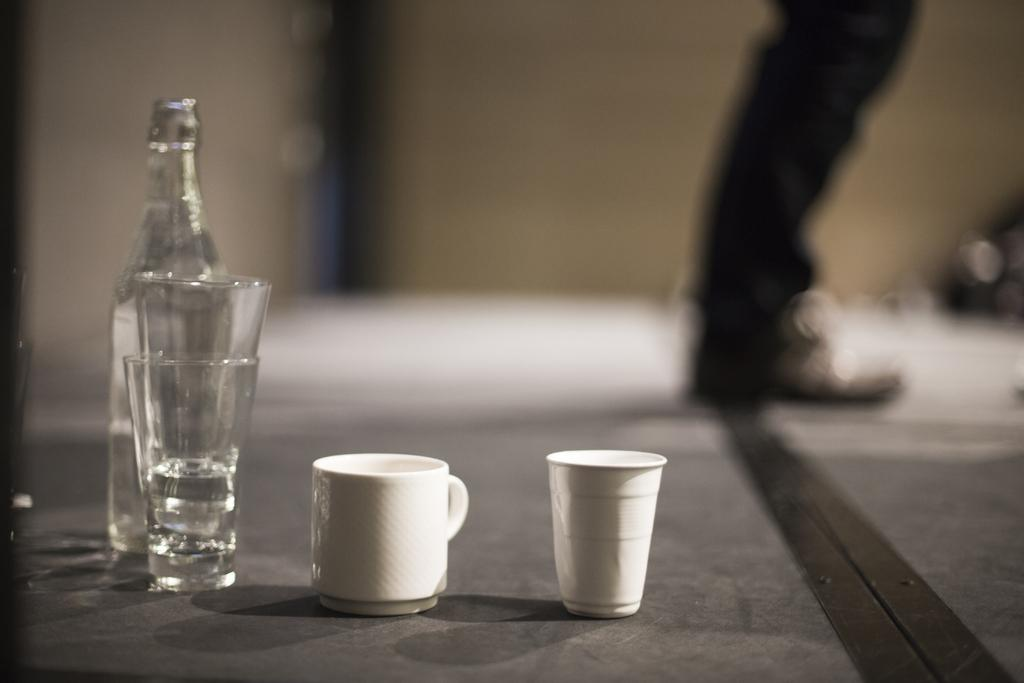What type of container is present in the image? There is a glass and a cup in the image. How many glasses are visible in the image? There are two glasses in the image. What other object can be seen in the image? There is a bottle in the image. Can you describe anything in the background of the image? A leg is visible in the background of the image. What type of property is being developed in the image? There is no information about property or development in the image. Can you point out the spot where the development is taking place? There is no development or spot related to development in the image. 